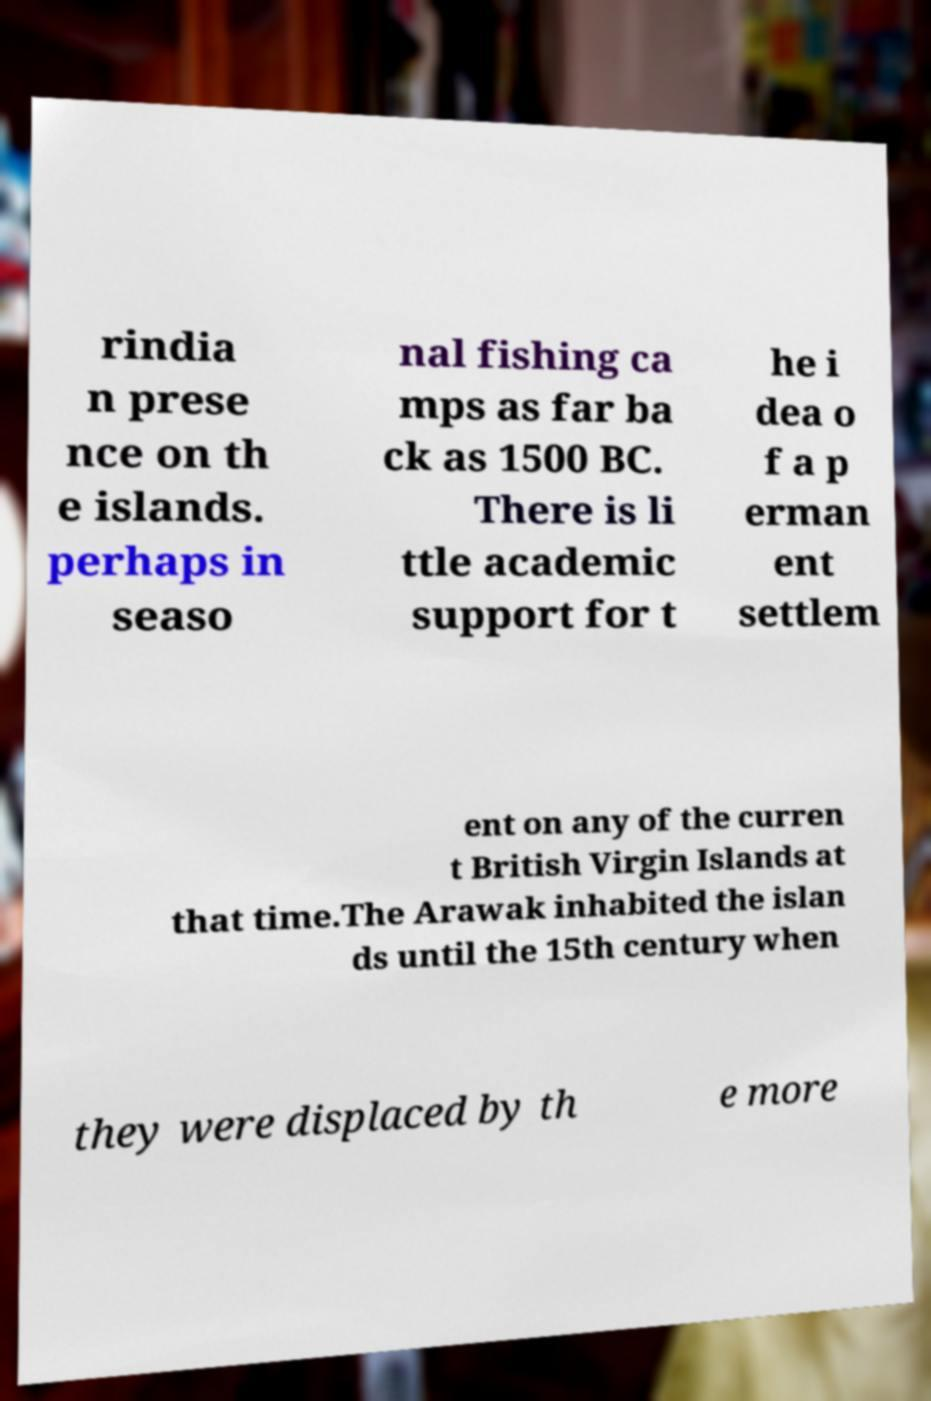Please identify and transcribe the text found in this image. rindia n prese nce on th e islands. perhaps in seaso nal fishing ca mps as far ba ck as 1500 BC. There is li ttle academic support for t he i dea o f a p erman ent settlem ent on any of the curren t British Virgin Islands at that time.The Arawak inhabited the islan ds until the 15th century when they were displaced by th e more 